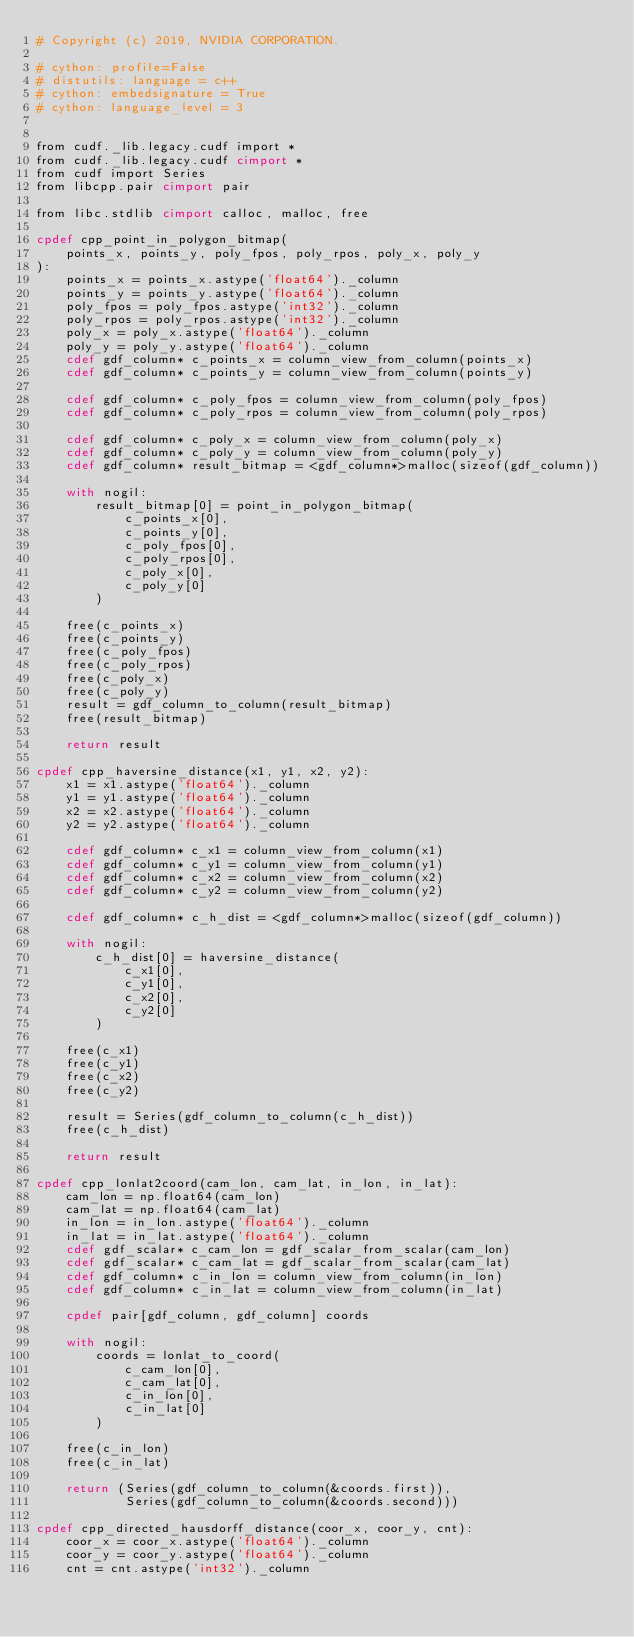Convert code to text. <code><loc_0><loc_0><loc_500><loc_500><_Cython_># Copyright (c) 2019, NVIDIA CORPORATION.

# cython: profile=False
# distutils: language = c++
# cython: embedsignature = True
# cython: language_level = 3


from cudf._lib.legacy.cudf import *
from cudf._lib.legacy.cudf cimport *
from cudf import Series
from libcpp.pair cimport pair

from libc.stdlib cimport calloc, malloc, free

cpdef cpp_point_in_polygon_bitmap(
    points_x, points_y, poly_fpos, poly_rpos, poly_x, poly_y
):
    points_x = points_x.astype('float64')._column
    points_y = points_y.astype('float64')._column
    poly_fpos = poly_fpos.astype('int32')._column
    poly_rpos = poly_rpos.astype('int32')._column
    poly_x = poly_x.astype('float64')._column
    poly_y = poly_y.astype('float64')._column
    cdef gdf_column* c_points_x = column_view_from_column(points_x)
    cdef gdf_column* c_points_y = column_view_from_column(points_y)

    cdef gdf_column* c_poly_fpos = column_view_from_column(poly_fpos)
    cdef gdf_column* c_poly_rpos = column_view_from_column(poly_rpos)

    cdef gdf_column* c_poly_x = column_view_from_column(poly_x)
    cdef gdf_column* c_poly_y = column_view_from_column(poly_y)
    cdef gdf_column* result_bitmap = <gdf_column*>malloc(sizeof(gdf_column))

    with nogil:
        result_bitmap[0] = point_in_polygon_bitmap(
            c_points_x[0],
            c_points_y[0],
            c_poly_fpos[0],
            c_poly_rpos[0],
            c_poly_x[0],
            c_poly_y[0]
        )

    free(c_points_x)
    free(c_points_y)
    free(c_poly_fpos)
    free(c_poly_rpos)
    free(c_poly_x)
    free(c_poly_y)
    result = gdf_column_to_column(result_bitmap)
    free(result_bitmap)

    return result

cpdef cpp_haversine_distance(x1, y1, x2, y2):
    x1 = x1.astype('float64')._column
    y1 = y1.astype('float64')._column
    x2 = x2.astype('float64')._column
    y2 = y2.astype('float64')._column

    cdef gdf_column* c_x1 = column_view_from_column(x1)
    cdef gdf_column* c_y1 = column_view_from_column(y1)
    cdef gdf_column* c_x2 = column_view_from_column(x2)
    cdef gdf_column* c_y2 = column_view_from_column(y2)

    cdef gdf_column* c_h_dist = <gdf_column*>malloc(sizeof(gdf_column))

    with nogil:
        c_h_dist[0] = haversine_distance(
            c_x1[0],
            c_y1[0],
            c_x2[0],
            c_y2[0]
        )

    free(c_x1)
    free(c_y1)
    free(c_x2)
    free(c_y2)

    result = Series(gdf_column_to_column(c_h_dist))
    free(c_h_dist)

    return result

cpdef cpp_lonlat2coord(cam_lon, cam_lat, in_lon, in_lat):
    cam_lon = np.float64(cam_lon)
    cam_lat = np.float64(cam_lat)
    in_lon = in_lon.astype('float64')._column
    in_lat = in_lat.astype('float64')._column
    cdef gdf_scalar* c_cam_lon = gdf_scalar_from_scalar(cam_lon)
    cdef gdf_scalar* c_cam_lat = gdf_scalar_from_scalar(cam_lat)
    cdef gdf_column* c_in_lon = column_view_from_column(in_lon)
    cdef gdf_column* c_in_lat = column_view_from_column(in_lat)

    cpdef pair[gdf_column, gdf_column] coords

    with nogil:
        coords = lonlat_to_coord(
            c_cam_lon[0],
            c_cam_lat[0],
            c_in_lon[0],
            c_in_lat[0]
        )

    free(c_in_lon)
    free(c_in_lat)

    return (Series(gdf_column_to_column(&coords.first)),
            Series(gdf_column_to_column(&coords.second)))

cpdef cpp_directed_hausdorff_distance(coor_x, coor_y, cnt):
    coor_x = coor_x.astype('float64')._column
    coor_y = coor_y.astype('float64')._column
    cnt = cnt.astype('int32')._column</code> 